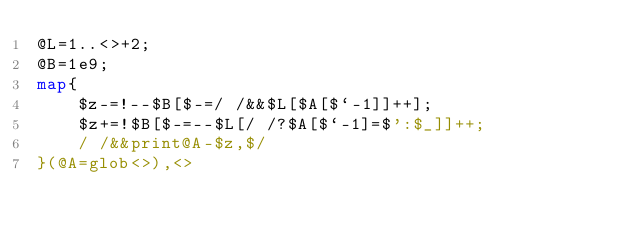<code> <loc_0><loc_0><loc_500><loc_500><_Perl_>@L=1..<>+2;
@B=1e9;
map{
	$z-=!--$B[$-=/ /&&$L[$A[$`-1]]++];
	$z+=!$B[$-=--$L[/ /?$A[$`-1]=$':$_]]++;
	/ /&&print@A-$z,$/
}(@A=glob<>),<>
</code> 